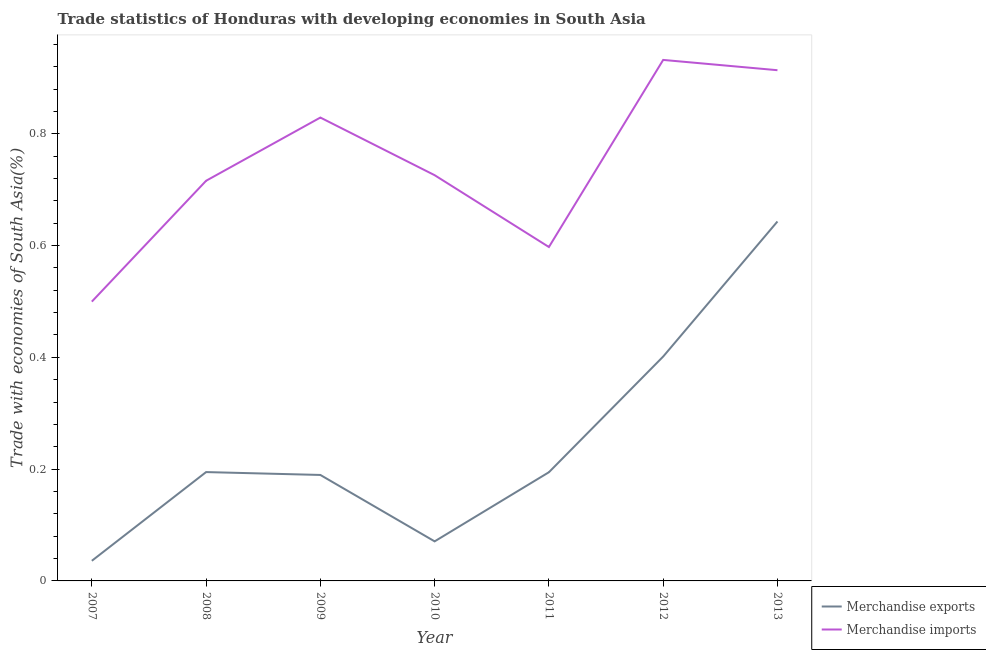Does the line corresponding to merchandise exports intersect with the line corresponding to merchandise imports?
Keep it short and to the point. No. Is the number of lines equal to the number of legend labels?
Provide a short and direct response. Yes. What is the merchandise exports in 2007?
Provide a short and direct response. 0.04. Across all years, what is the maximum merchandise exports?
Your response must be concise. 0.64. Across all years, what is the minimum merchandise exports?
Provide a short and direct response. 0.04. In which year was the merchandise exports maximum?
Your answer should be very brief. 2013. In which year was the merchandise imports minimum?
Your response must be concise. 2007. What is the total merchandise exports in the graph?
Ensure brevity in your answer.  1.73. What is the difference between the merchandise imports in 2010 and that in 2012?
Provide a succinct answer. -0.21. What is the difference between the merchandise imports in 2011 and the merchandise exports in 2008?
Keep it short and to the point. 0.4. What is the average merchandise imports per year?
Your answer should be compact. 0.74. In the year 2009, what is the difference between the merchandise imports and merchandise exports?
Provide a short and direct response. 0.64. What is the ratio of the merchandise imports in 2007 to that in 2008?
Offer a very short reply. 0.7. What is the difference between the highest and the second highest merchandise exports?
Your answer should be compact. 0.24. What is the difference between the highest and the lowest merchandise imports?
Offer a terse response. 0.43. In how many years, is the merchandise exports greater than the average merchandise exports taken over all years?
Give a very brief answer. 2. Is the sum of the merchandise exports in 2011 and 2013 greater than the maximum merchandise imports across all years?
Your response must be concise. No. Does the merchandise imports monotonically increase over the years?
Make the answer very short. No. Is the merchandise exports strictly greater than the merchandise imports over the years?
Offer a terse response. No. How many lines are there?
Your answer should be compact. 2. Does the graph contain any zero values?
Provide a short and direct response. No. Does the graph contain grids?
Your response must be concise. No. Where does the legend appear in the graph?
Your answer should be very brief. Bottom right. How many legend labels are there?
Provide a short and direct response. 2. What is the title of the graph?
Keep it short and to the point. Trade statistics of Honduras with developing economies in South Asia. What is the label or title of the X-axis?
Offer a very short reply. Year. What is the label or title of the Y-axis?
Ensure brevity in your answer.  Trade with economies of South Asia(%). What is the Trade with economies of South Asia(%) in Merchandise exports in 2007?
Provide a short and direct response. 0.04. What is the Trade with economies of South Asia(%) of Merchandise imports in 2007?
Offer a terse response. 0.5. What is the Trade with economies of South Asia(%) of Merchandise exports in 2008?
Your answer should be compact. 0.19. What is the Trade with economies of South Asia(%) in Merchandise imports in 2008?
Ensure brevity in your answer.  0.72. What is the Trade with economies of South Asia(%) in Merchandise exports in 2009?
Offer a very short reply. 0.19. What is the Trade with economies of South Asia(%) in Merchandise imports in 2009?
Provide a short and direct response. 0.83. What is the Trade with economies of South Asia(%) in Merchandise exports in 2010?
Your answer should be very brief. 0.07. What is the Trade with economies of South Asia(%) of Merchandise imports in 2010?
Give a very brief answer. 0.73. What is the Trade with economies of South Asia(%) of Merchandise exports in 2011?
Your response must be concise. 0.19. What is the Trade with economies of South Asia(%) of Merchandise imports in 2011?
Give a very brief answer. 0.6. What is the Trade with economies of South Asia(%) of Merchandise exports in 2012?
Give a very brief answer. 0.4. What is the Trade with economies of South Asia(%) in Merchandise imports in 2012?
Your answer should be very brief. 0.93. What is the Trade with economies of South Asia(%) of Merchandise exports in 2013?
Keep it short and to the point. 0.64. What is the Trade with economies of South Asia(%) in Merchandise imports in 2013?
Give a very brief answer. 0.91. Across all years, what is the maximum Trade with economies of South Asia(%) in Merchandise exports?
Your answer should be very brief. 0.64. Across all years, what is the maximum Trade with economies of South Asia(%) of Merchandise imports?
Provide a succinct answer. 0.93. Across all years, what is the minimum Trade with economies of South Asia(%) of Merchandise exports?
Your answer should be compact. 0.04. Across all years, what is the minimum Trade with economies of South Asia(%) of Merchandise imports?
Your answer should be compact. 0.5. What is the total Trade with economies of South Asia(%) of Merchandise exports in the graph?
Make the answer very short. 1.73. What is the total Trade with economies of South Asia(%) in Merchandise imports in the graph?
Make the answer very short. 5.21. What is the difference between the Trade with economies of South Asia(%) in Merchandise exports in 2007 and that in 2008?
Ensure brevity in your answer.  -0.16. What is the difference between the Trade with economies of South Asia(%) of Merchandise imports in 2007 and that in 2008?
Offer a terse response. -0.22. What is the difference between the Trade with economies of South Asia(%) of Merchandise exports in 2007 and that in 2009?
Provide a succinct answer. -0.15. What is the difference between the Trade with economies of South Asia(%) in Merchandise imports in 2007 and that in 2009?
Your response must be concise. -0.33. What is the difference between the Trade with economies of South Asia(%) in Merchandise exports in 2007 and that in 2010?
Your answer should be compact. -0.03. What is the difference between the Trade with economies of South Asia(%) in Merchandise imports in 2007 and that in 2010?
Offer a very short reply. -0.23. What is the difference between the Trade with economies of South Asia(%) of Merchandise exports in 2007 and that in 2011?
Your answer should be very brief. -0.16. What is the difference between the Trade with economies of South Asia(%) of Merchandise imports in 2007 and that in 2011?
Give a very brief answer. -0.1. What is the difference between the Trade with economies of South Asia(%) in Merchandise exports in 2007 and that in 2012?
Your answer should be very brief. -0.37. What is the difference between the Trade with economies of South Asia(%) in Merchandise imports in 2007 and that in 2012?
Your response must be concise. -0.43. What is the difference between the Trade with economies of South Asia(%) in Merchandise exports in 2007 and that in 2013?
Provide a short and direct response. -0.61. What is the difference between the Trade with economies of South Asia(%) in Merchandise imports in 2007 and that in 2013?
Keep it short and to the point. -0.41. What is the difference between the Trade with economies of South Asia(%) in Merchandise exports in 2008 and that in 2009?
Provide a succinct answer. 0.01. What is the difference between the Trade with economies of South Asia(%) of Merchandise imports in 2008 and that in 2009?
Give a very brief answer. -0.11. What is the difference between the Trade with economies of South Asia(%) in Merchandise exports in 2008 and that in 2010?
Make the answer very short. 0.12. What is the difference between the Trade with economies of South Asia(%) in Merchandise imports in 2008 and that in 2010?
Offer a very short reply. -0.01. What is the difference between the Trade with economies of South Asia(%) of Merchandise exports in 2008 and that in 2011?
Your response must be concise. 0. What is the difference between the Trade with economies of South Asia(%) of Merchandise imports in 2008 and that in 2011?
Ensure brevity in your answer.  0.12. What is the difference between the Trade with economies of South Asia(%) in Merchandise exports in 2008 and that in 2012?
Your answer should be very brief. -0.21. What is the difference between the Trade with economies of South Asia(%) of Merchandise imports in 2008 and that in 2012?
Ensure brevity in your answer.  -0.22. What is the difference between the Trade with economies of South Asia(%) in Merchandise exports in 2008 and that in 2013?
Provide a short and direct response. -0.45. What is the difference between the Trade with economies of South Asia(%) of Merchandise imports in 2008 and that in 2013?
Your answer should be compact. -0.2. What is the difference between the Trade with economies of South Asia(%) in Merchandise exports in 2009 and that in 2010?
Ensure brevity in your answer.  0.12. What is the difference between the Trade with economies of South Asia(%) of Merchandise imports in 2009 and that in 2010?
Give a very brief answer. 0.1. What is the difference between the Trade with economies of South Asia(%) of Merchandise exports in 2009 and that in 2011?
Provide a succinct answer. -0. What is the difference between the Trade with economies of South Asia(%) of Merchandise imports in 2009 and that in 2011?
Ensure brevity in your answer.  0.23. What is the difference between the Trade with economies of South Asia(%) of Merchandise exports in 2009 and that in 2012?
Provide a short and direct response. -0.21. What is the difference between the Trade with economies of South Asia(%) of Merchandise imports in 2009 and that in 2012?
Ensure brevity in your answer.  -0.1. What is the difference between the Trade with economies of South Asia(%) of Merchandise exports in 2009 and that in 2013?
Your answer should be compact. -0.45. What is the difference between the Trade with economies of South Asia(%) in Merchandise imports in 2009 and that in 2013?
Offer a terse response. -0.08. What is the difference between the Trade with economies of South Asia(%) of Merchandise exports in 2010 and that in 2011?
Your answer should be compact. -0.12. What is the difference between the Trade with economies of South Asia(%) of Merchandise imports in 2010 and that in 2011?
Your answer should be very brief. 0.13. What is the difference between the Trade with economies of South Asia(%) of Merchandise exports in 2010 and that in 2012?
Your answer should be compact. -0.33. What is the difference between the Trade with economies of South Asia(%) in Merchandise imports in 2010 and that in 2012?
Offer a terse response. -0.21. What is the difference between the Trade with economies of South Asia(%) in Merchandise exports in 2010 and that in 2013?
Keep it short and to the point. -0.57. What is the difference between the Trade with economies of South Asia(%) in Merchandise imports in 2010 and that in 2013?
Your answer should be very brief. -0.19. What is the difference between the Trade with economies of South Asia(%) of Merchandise exports in 2011 and that in 2012?
Keep it short and to the point. -0.21. What is the difference between the Trade with economies of South Asia(%) of Merchandise imports in 2011 and that in 2012?
Provide a short and direct response. -0.33. What is the difference between the Trade with economies of South Asia(%) in Merchandise exports in 2011 and that in 2013?
Provide a short and direct response. -0.45. What is the difference between the Trade with economies of South Asia(%) of Merchandise imports in 2011 and that in 2013?
Provide a short and direct response. -0.32. What is the difference between the Trade with economies of South Asia(%) of Merchandise exports in 2012 and that in 2013?
Make the answer very short. -0.24. What is the difference between the Trade with economies of South Asia(%) of Merchandise imports in 2012 and that in 2013?
Provide a succinct answer. 0.02. What is the difference between the Trade with economies of South Asia(%) in Merchandise exports in 2007 and the Trade with economies of South Asia(%) in Merchandise imports in 2008?
Make the answer very short. -0.68. What is the difference between the Trade with economies of South Asia(%) in Merchandise exports in 2007 and the Trade with economies of South Asia(%) in Merchandise imports in 2009?
Give a very brief answer. -0.79. What is the difference between the Trade with economies of South Asia(%) in Merchandise exports in 2007 and the Trade with economies of South Asia(%) in Merchandise imports in 2010?
Your answer should be very brief. -0.69. What is the difference between the Trade with economies of South Asia(%) of Merchandise exports in 2007 and the Trade with economies of South Asia(%) of Merchandise imports in 2011?
Make the answer very short. -0.56. What is the difference between the Trade with economies of South Asia(%) in Merchandise exports in 2007 and the Trade with economies of South Asia(%) in Merchandise imports in 2012?
Keep it short and to the point. -0.9. What is the difference between the Trade with economies of South Asia(%) of Merchandise exports in 2007 and the Trade with economies of South Asia(%) of Merchandise imports in 2013?
Your response must be concise. -0.88. What is the difference between the Trade with economies of South Asia(%) of Merchandise exports in 2008 and the Trade with economies of South Asia(%) of Merchandise imports in 2009?
Offer a terse response. -0.63. What is the difference between the Trade with economies of South Asia(%) in Merchandise exports in 2008 and the Trade with economies of South Asia(%) in Merchandise imports in 2010?
Ensure brevity in your answer.  -0.53. What is the difference between the Trade with economies of South Asia(%) of Merchandise exports in 2008 and the Trade with economies of South Asia(%) of Merchandise imports in 2011?
Provide a short and direct response. -0.4. What is the difference between the Trade with economies of South Asia(%) in Merchandise exports in 2008 and the Trade with economies of South Asia(%) in Merchandise imports in 2012?
Offer a very short reply. -0.74. What is the difference between the Trade with economies of South Asia(%) of Merchandise exports in 2008 and the Trade with economies of South Asia(%) of Merchandise imports in 2013?
Provide a short and direct response. -0.72. What is the difference between the Trade with economies of South Asia(%) in Merchandise exports in 2009 and the Trade with economies of South Asia(%) in Merchandise imports in 2010?
Give a very brief answer. -0.54. What is the difference between the Trade with economies of South Asia(%) of Merchandise exports in 2009 and the Trade with economies of South Asia(%) of Merchandise imports in 2011?
Offer a very short reply. -0.41. What is the difference between the Trade with economies of South Asia(%) in Merchandise exports in 2009 and the Trade with economies of South Asia(%) in Merchandise imports in 2012?
Offer a terse response. -0.74. What is the difference between the Trade with economies of South Asia(%) in Merchandise exports in 2009 and the Trade with economies of South Asia(%) in Merchandise imports in 2013?
Offer a very short reply. -0.72. What is the difference between the Trade with economies of South Asia(%) in Merchandise exports in 2010 and the Trade with economies of South Asia(%) in Merchandise imports in 2011?
Your answer should be compact. -0.53. What is the difference between the Trade with economies of South Asia(%) of Merchandise exports in 2010 and the Trade with economies of South Asia(%) of Merchandise imports in 2012?
Make the answer very short. -0.86. What is the difference between the Trade with economies of South Asia(%) of Merchandise exports in 2010 and the Trade with economies of South Asia(%) of Merchandise imports in 2013?
Give a very brief answer. -0.84. What is the difference between the Trade with economies of South Asia(%) in Merchandise exports in 2011 and the Trade with economies of South Asia(%) in Merchandise imports in 2012?
Ensure brevity in your answer.  -0.74. What is the difference between the Trade with economies of South Asia(%) of Merchandise exports in 2011 and the Trade with economies of South Asia(%) of Merchandise imports in 2013?
Your answer should be very brief. -0.72. What is the difference between the Trade with economies of South Asia(%) of Merchandise exports in 2012 and the Trade with economies of South Asia(%) of Merchandise imports in 2013?
Provide a short and direct response. -0.51. What is the average Trade with economies of South Asia(%) of Merchandise exports per year?
Make the answer very short. 0.25. What is the average Trade with economies of South Asia(%) of Merchandise imports per year?
Make the answer very short. 0.74. In the year 2007, what is the difference between the Trade with economies of South Asia(%) of Merchandise exports and Trade with economies of South Asia(%) of Merchandise imports?
Your answer should be compact. -0.46. In the year 2008, what is the difference between the Trade with economies of South Asia(%) in Merchandise exports and Trade with economies of South Asia(%) in Merchandise imports?
Your answer should be very brief. -0.52. In the year 2009, what is the difference between the Trade with economies of South Asia(%) in Merchandise exports and Trade with economies of South Asia(%) in Merchandise imports?
Offer a terse response. -0.64. In the year 2010, what is the difference between the Trade with economies of South Asia(%) of Merchandise exports and Trade with economies of South Asia(%) of Merchandise imports?
Your response must be concise. -0.66. In the year 2011, what is the difference between the Trade with economies of South Asia(%) in Merchandise exports and Trade with economies of South Asia(%) in Merchandise imports?
Keep it short and to the point. -0.4. In the year 2012, what is the difference between the Trade with economies of South Asia(%) in Merchandise exports and Trade with economies of South Asia(%) in Merchandise imports?
Your response must be concise. -0.53. In the year 2013, what is the difference between the Trade with economies of South Asia(%) of Merchandise exports and Trade with economies of South Asia(%) of Merchandise imports?
Provide a short and direct response. -0.27. What is the ratio of the Trade with economies of South Asia(%) of Merchandise exports in 2007 to that in 2008?
Give a very brief answer. 0.18. What is the ratio of the Trade with economies of South Asia(%) of Merchandise imports in 2007 to that in 2008?
Provide a short and direct response. 0.7. What is the ratio of the Trade with economies of South Asia(%) of Merchandise exports in 2007 to that in 2009?
Make the answer very short. 0.19. What is the ratio of the Trade with economies of South Asia(%) in Merchandise imports in 2007 to that in 2009?
Keep it short and to the point. 0.6. What is the ratio of the Trade with economies of South Asia(%) in Merchandise exports in 2007 to that in 2010?
Your answer should be compact. 0.51. What is the ratio of the Trade with economies of South Asia(%) in Merchandise imports in 2007 to that in 2010?
Your response must be concise. 0.69. What is the ratio of the Trade with economies of South Asia(%) in Merchandise exports in 2007 to that in 2011?
Give a very brief answer. 0.19. What is the ratio of the Trade with economies of South Asia(%) of Merchandise imports in 2007 to that in 2011?
Offer a terse response. 0.84. What is the ratio of the Trade with economies of South Asia(%) in Merchandise exports in 2007 to that in 2012?
Your response must be concise. 0.09. What is the ratio of the Trade with economies of South Asia(%) in Merchandise imports in 2007 to that in 2012?
Your answer should be compact. 0.54. What is the ratio of the Trade with economies of South Asia(%) in Merchandise exports in 2007 to that in 2013?
Offer a very short reply. 0.06. What is the ratio of the Trade with economies of South Asia(%) of Merchandise imports in 2007 to that in 2013?
Provide a succinct answer. 0.55. What is the ratio of the Trade with economies of South Asia(%) in Merchandise exports in 2008 to that in 2009?
Your answer should be compact. 1.03. What is the ratio of the Trade with economies of South Asia(%) in Merchandise imports in 2008 to that in 2009?
Keep it short and to the point. 0.86. What is the ratio of the Trade with economies of South Asia(%) in Merchandise exports in 2008 to that in 2010?
Keep it short and to the point. 2.75. What is the ratio of the Trade with economies of South Asia(%) in Merchandise imports in 2008 to that in 2010?
Give a very brief answer. 0.99. What is the ratio of the Trade with economies of South Asia(%) of Merchandise exports in 2008 to that in 2011?
Offer a terse response. 1. What is the ratio of the Trade with economies of South Asia(%) in Merchandise imports in 2008 to that in 2011?
Ensure brevity in your answer.  1.2. What is the ratio of the Trade with economies of South Asia(%) of Merchandise exports in 2008 to that in 2012?
Keep it short and to the point. 0.49. What is the ratio of the Trade with economies of South Asia(%) in Merchandise imports in 2008 to that in 2012?
Offer a very short reply. 0.77. What is the ratio of the Trade with economies of South Asia(%) of Merchandise exports in 2008 to that in 2013?
Make the answer very short. 0.3. What is the ratio of the Trade with economies of South Asia(%) of Merchandise imports in 2008 to that in 2013?
Keep it short and to the point. 0.78. What is the ratio of the Trade with economies of South Asia(%) of Merchandise exports in 2009 to that in 2010?
Offer a very short reply. 2.68. What is the ratio of the Trade with economies of South Asia(%) of Merchandise imports in 2009 to that in 2010?
Offer a terse response. 1.14. What is the ratio of the Trade with economies of South Asia(%) of Merchandise exports in 2009 to that in 2011?
Provide a succinct answer. 0.97. What is the ratio of the Trade with economies of South Asia(%) in Merchandise imports in 2009 to that in 2011?
Ensure brevity in your answer.  1.39. What is the ratio of the Trade with economies of South Asia(%) in Merchandise exports in 2009 to that in 2012?
Your answer should be compact. 0.47. What is the ratio of the Trade with economies of South Asia(%) of Merchandise imports in 2009 to that in 2012?
Offer a terse response. 0.89. What is the ratio of the Trade with economies of South Asia(%) of Merchandise exports in 2009 to that in 2013?
Provide a short and direct response. 0.29. What is the ratio of the Trade with economies of South Asia(%) in Merchandise imports in 2009 to that in 2013?
Your response must be concise. 0.91. What is the ratio of the Trade with economies of South Asia(%) of Merchandise exports in 2010 to that in 2011?
Ensure brevity in your answer.  0.36. What is the ratio of the Trade with economies of South Asia(%) in Merchandise imports in 2010 to that in 2011?
Keep it short and to the point. 1.22. What is the ratio of the Trade with economies of South Asia(%) in Merchandise exports in 2010 to that in 2012?
Your answer should be very brief. 0.18. What is the ratio of the Trade with economies of South Asia(%) in Merchandise imports in 2010 to that in 2012?
Your answer should be very brief. 0.78. What is the ratio of the Trade with economies of South Asia(%) of Merchandise exports in 2010 to that in 2013?
Your answer should be compact. 0.11. What is the ratio of the Trade with economies of South Asia(%) of Merchandise imports in 2010 to that in 2013?
Make the answer very short. 0.79. What is the ratio of the Trade with economies of South Asia(%) in Merchandise exports in 2011 to that in 2012?
Offer a terse response. 0.48. What is the ratio of the Trade with economies of South Asia(%) in Merchandise imports in 2011 to that in 2012?
Your answer should be very brief. 0.64. What is the ratio of the Trade with economies of South Asia(%) in Merchandise exports in 2011 to that in 2013?
Keep it short and to the point. 0.3. What is the ratio of the Trade with economies of South Asia(%) of Merchandise imports in 2011 to that in 2013?
Your answer should be compact. 0.65. What is the ratio of the Trade with economies of South Asia(%) of Merchandise exports in 2012 to that in 2013?
Your response must be concise. 0.62. What is the ratio of the Trade with economies of South Asia(%) in Merchandise imports in 2012 to that in 2013?
Your answer should be very brief. 1.02. What is the difference between the highest and the second highest Trade with economies of South Asia(%) of Merchandise exports?
Ensure brevity in your answer.  0.24. What is the difference between the highest and the second highest Trade with economies of South Asia(%) in Merchandise imports?
Your response must be concise. 0.02. What is the difference between the highest and the lowest Trade with economies of South Asia(%) in Merchandise exports?
Offer a very short reply. 0.61. What is the difference between the highest and the lowest Trade with economies of South Asia(%) in Merchandise imports?
Make the answer very short. 0.43. 